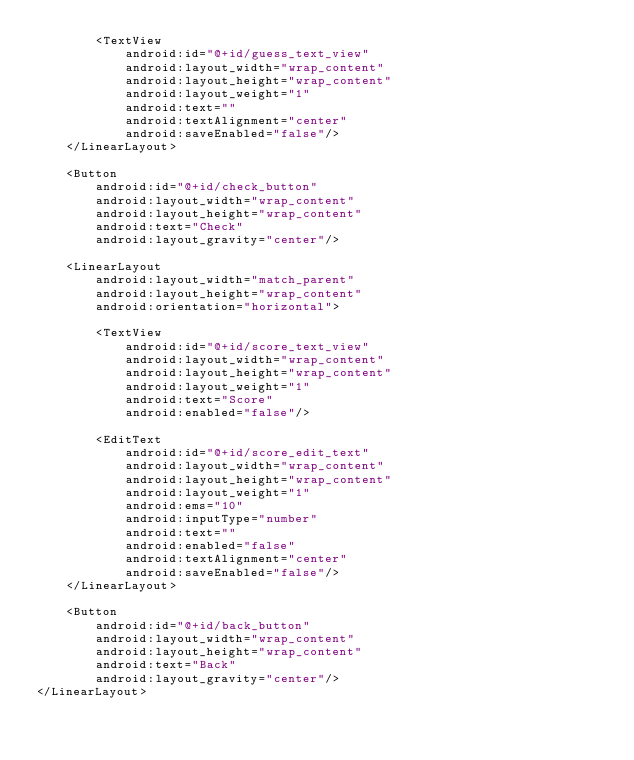<code> <loc_0><loc_0><loc_500><loc_500><_XML_>        <TextView
            android:id="@+id/guess_text_view"
            android:layout_width="wrap_content"
            android:layout_height="wrap_content"
            android:layout_weight="1"
            android:text=""
            android:textAlignment="center"
            android:saveEnabled="false"/>
    </LinearLayout>

    <Button
        android:id="@+id/check_button"
        android:layout_width="wrap_content"
        android:layout_height="wrap_content"
        android:text="Check"
        android:layout_gravity="center"/>

    <LinearLayout
        android:layout_width="match_parent"
        android:layout_height="wrap_content"
        android:orientation="horizontal">

        <TextView
            android:id="@+id/score_text_view"
            android:layout_width="wrap_content"
            android:layout_height="wrap_content"
            android:layout_weight="1"
            android:text="Score"
            android:enabled="false"/>

        <EditText
            android:id="@+id/score_edit_text"
            android:layout_width="wrap_content"
            android:layout_height="wrap_content"
            android:layout_weight="1"
            android:ems="10"
            android:inputType="number"
            android:text=""
            android:enabled="false"
            android:textAlignment="center"
            android:saveEnabled="false"/>
    </LinearLayout>

    <Button
        android:id="@+id/back_button"
        android:layout_width="wrap_content"
        android:layout_height="wrap_content"
        android:text="Back"
        android:layout_gravity="center"/>
</LinearLayout></code> 